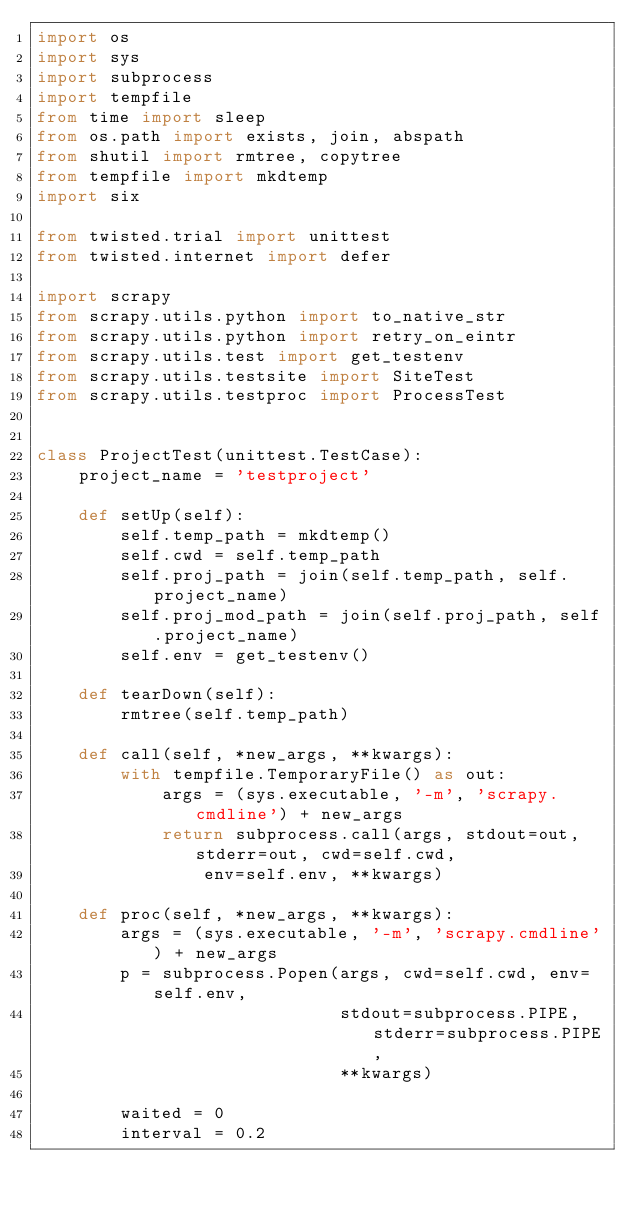<code> <loc_0><loc_0><loc_500><loc_500><_Python_>import os
import sys
import subprocess
import tempfile
from time import sleep
from os.path import exists, join, abspath
from shutil import rmtree, copytree
from tempfile import mkdtemp
import six

from twisted.trial import unittest
from twisted.internet import defer

import scrapy
from scrapy.utils.python import to_native_str
from scrapy.utils.python import retry_on_eintr
from scrapy.utils.test import get_testenv
from scrapy.utils.testsite import SiteTest
from scrapy.utils.testproc import ProcessTest


class ProjectTest(unittest.TestCase):
    project_name = 'testproject'

    def setUp(self):
        self.temp_path = mkdtemp()
        self.cwd = self.temp_path
        self.proj_path = join(self.temp_path, self.project_name)
        self.proj_mod_path = join(self.proj_path, self.project_name)
        self.env = get_testenv()

    def tearDown(self):
        rmtree(self.temp_path)

    def call(self, *new_args, **kwargs):
        with tempfile.TemporaryFile() as out:
            args = (sys.executable, '-m', 'scrapy.cmdline') + new_args
            return subprocess.call(args, stdout=out, stderr=out, cwd=self.cwd,
                env=self.env, **kwargs)

    def proc(self, *new_args, **kwargs):
        args = (sys.executable, '-m', 'scrapy.cmdline') + new_args
        p = subprocess.Popen(args, cwd=self.cwd, env=self.env,
                             stdout=subprocess.PIPE, stderr=subprocess.PIPE,
                             **kwargs)

        waited = 0
        interval = 0.2</code> 